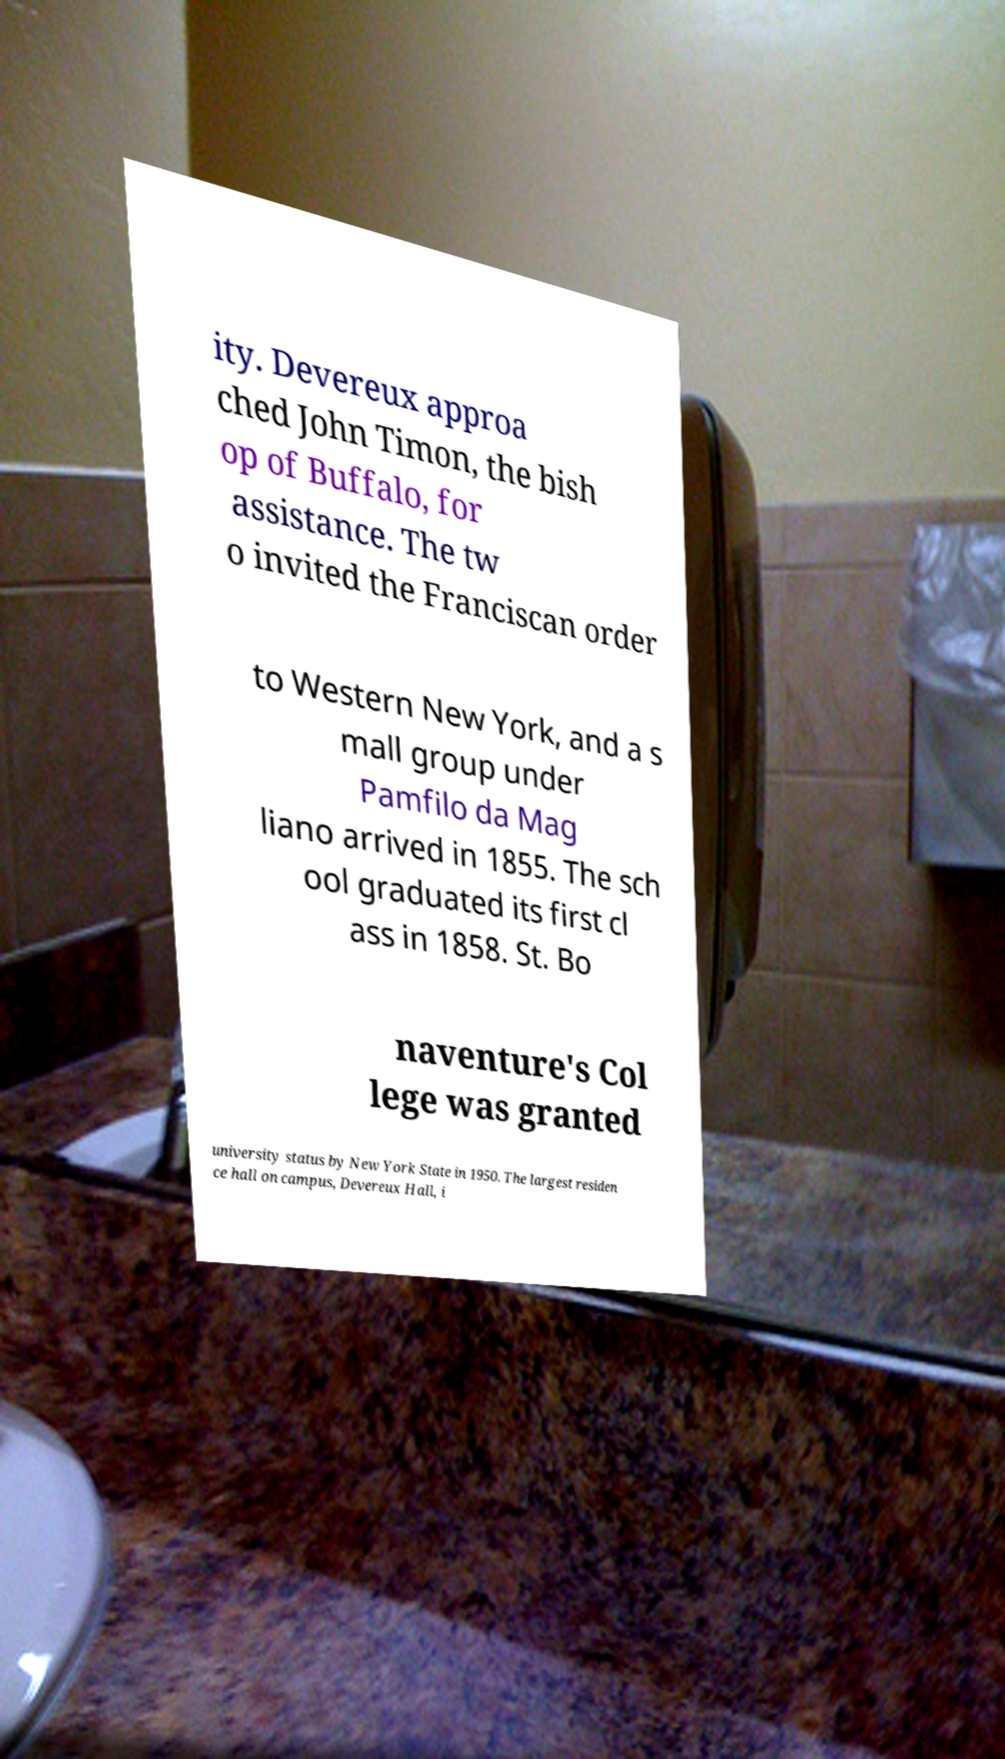Can you read and provide the text displayed in the image?This photo seems to have some interesting text. Can you extract and type it out for me? ity. Devereux approa ched John Timon, the bish op of Buffalo, for assistance. The tw o invited the Franciscan order to Western New York, and a s mall group under Pamfilo da Mag liano arrived in 1855. The sch ool graduated its first cl ass in 1858. St. Bo naventure's Col lege was granted university status by New York State in 1950. The largest residen ce hall on campus, Devereux Hall, i 